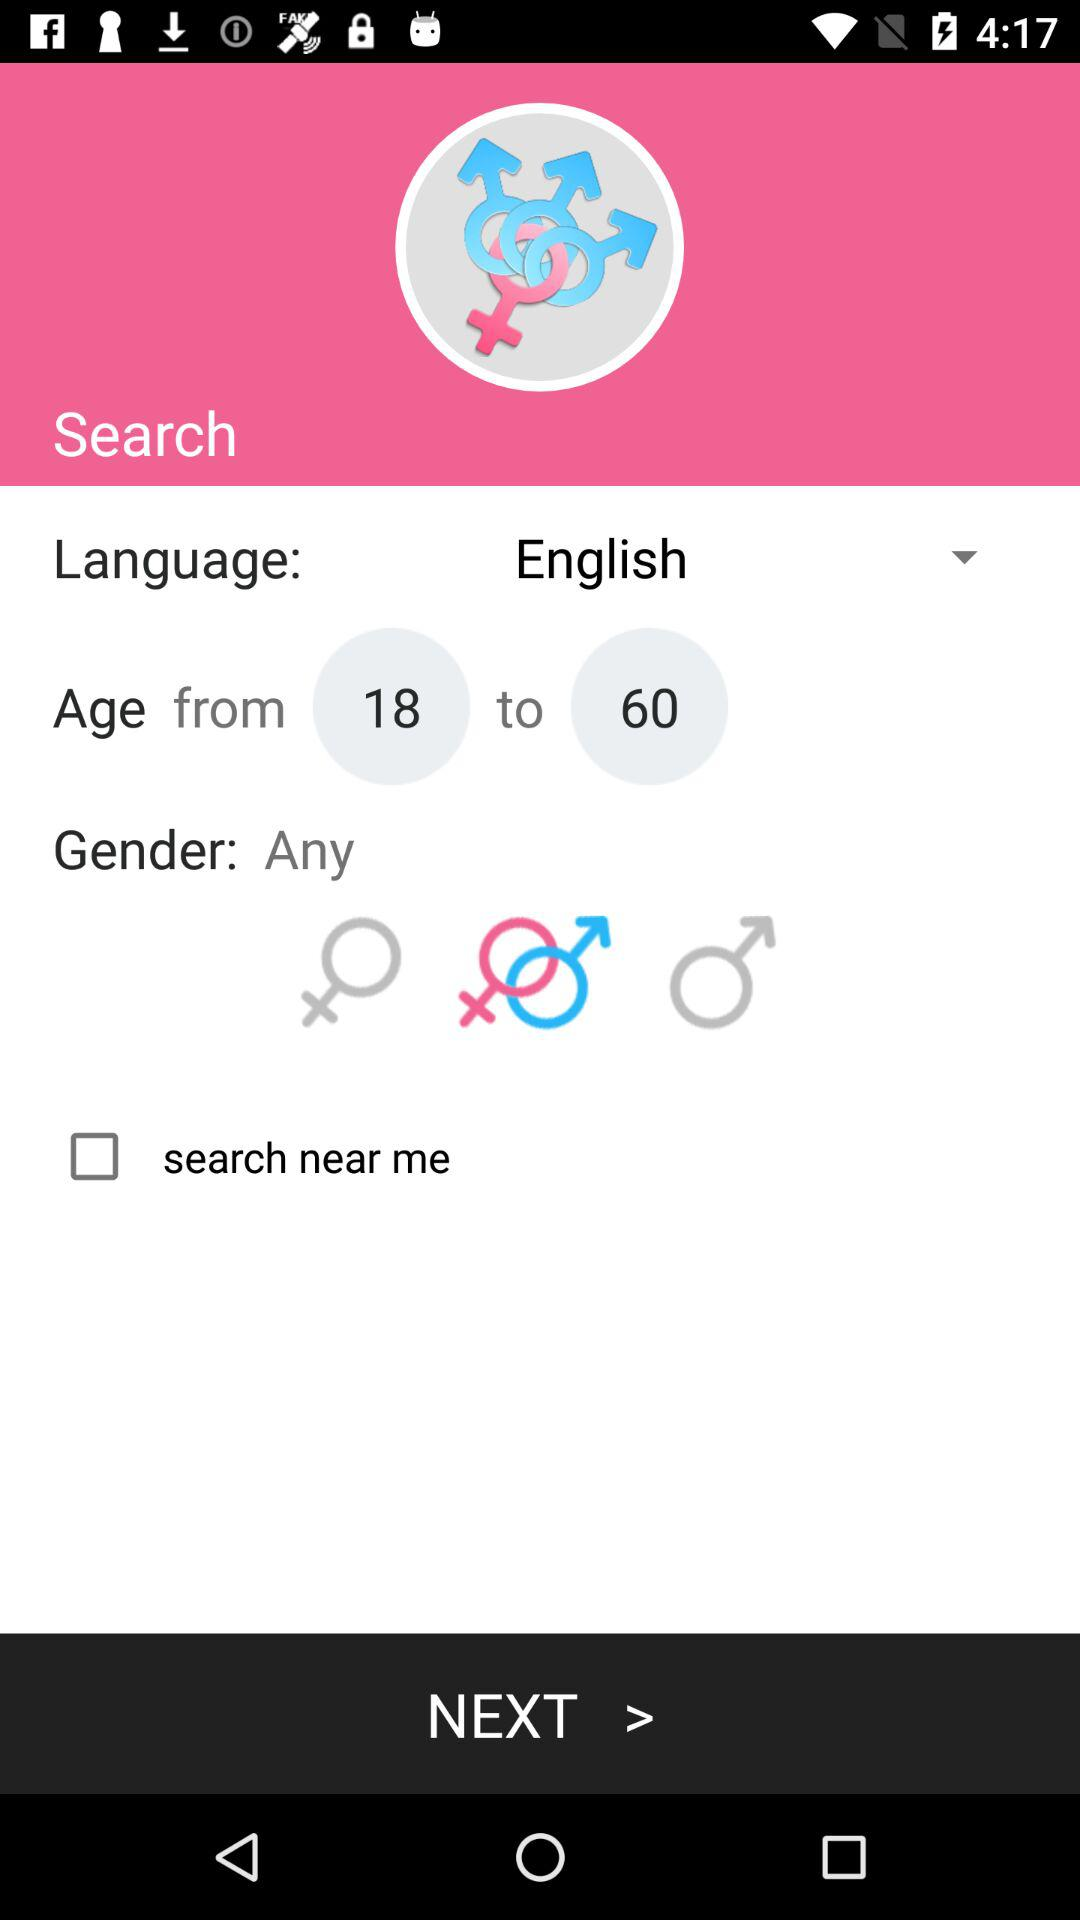Which language is used for searching? The language is English. 